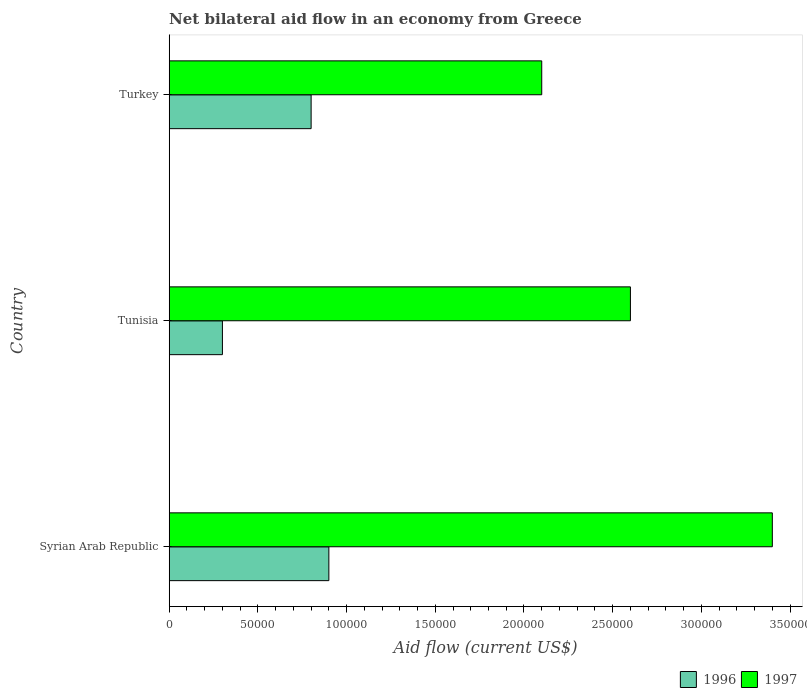How many different coloured bars are there?
Provide a short and direct response. 2. Are the number of bars per tick equal to the number of legend labels?
Your answer should be very brief. Yes. Are the number of bars on each tick of the Y-axis equal?
Your response must be concise. Yes. In how many cases, is the number of bars for a given country not equal to the number of legend labels?
Make the answer very short. 0. In which country was the net bilateral aid flow in 1996 maximum?
Provide a short and direct response. Syrian Arab Republic. In which country was the net bilateral aid flow in 1997 minimum?
Your response must be concise. Turkey. What is the total net bilateral aid flow in 1996 in the graph?
Ensure brevity in your answer.  2.00e+05. What is the difference between the net bilateral aid flow in 1997 in Syrian Arab Republic and that in Tunisia?
Ensure brevity in your answer.  8.00e+04. In how many countries, is the net bilateral aid flow in 1997 greater than 60000 US$?
Provide a succinct answer. 3. What is the ratio of the net bilateral aid flow in 1997 in Syrian Arab Republic to that in Turkey?
Give a very brief answer. 1.62. In how many countries, is the net bilateral aid flow in 1997 greater than the average net bilateral aid flow in 1997 taken over all countries?
Make the answer very short. 1. Is the sum of the net bilateral aid flow in 1996 in Tunisia and Turkey greater than the maximum net bilateral aid flow in 1997 across all countries?
Your response must be concise. No. What does the 1st bar from the top in Turkey represents?
Offer a terse response. 1997. How many countries are there in the graph?
Ensure brevity in your answer.  3. What is the difference between two consecutive major ticks on the X-axis?
Ensure brevity in your answer.  5.00e+04. Where does the legend appear in the graph?
Keep it short and to the point. Bottom right. How many legend labels are there?
Keep it short and to the point. 2. What is the title of the graph?
Provide a short and direct response. Net bilateral aid flow in an economy from Greece. What is the label or title of the X-axis?
Make the answer very short. Aid flow (current US$). What is the label or title of the Y-axis?
Keep it short and to the point. Country. What is the Aid flow (current US$) in 1996 in Tunisia?
Your answer should be compact. 3.00e+04. What is the Aid flow (current US$) in 1997 in Tunisia?
Your answer should be compact. 2.60e+05. What is the Aid flow (current US$) of 1997 in Turkey?
Your answer should be compact. 2.10e+05. Across all countries, what is the maximum Aid flow (current US$) in 1996?
Your answer should be compact. 9.00e+04. Across all countries, what is the maximum Aid flow (current US$) of 1997?
Your answer should be compact. 3.40e+05. What is the total Aid flow (current US$) of 1997 in the graph?
Provide a short and direct response. 8.10e+05. What is the difference between the Aid flow (current US$) of 1997 in Syrian Arab Republic and that in Tunisia?
Provide a succinct answer. 8.00e+04. What is the difference between the Aid flow (current US$) of 1996 in Syrian Arab Republic and that in Turkey?
Provide a short and direct response. 10000. What is the difference between the Aid flow (current US$) of 1997 in Syrian Arab Republic and that in Turkey?
Your answer should be compact. 1.30e+05. What is the difference between the Aid flow (current US$) in 1996 in Syrian Arab Republic and the Aid flow (current US$) in 1997 in Tunisia?
Keep it short and to the point. -1.70e+05. What is the difference between the Aid flow (current US$) of 1996 in Syrian Arab Republic and the Aid flow (current US$) of 1997 in Turkey?
Provide a succinct answer. -1.20e+05. What is the difference between the Aid flow (current US$) in 1996 in Tunisia and the Aid flow (current US$) in 1997 in Turkey?
Provide a succinct answer. -1.80e+05. What is the average Aid flow (current US$) of 1996 per country?
Offer a terse response. 6.67e+04. What is the ratio of the Aid flow (current US$) of 1996 in Syrian Arab Republic to that in Tunisia?
Offer a terse response. 3. What is the ratio of the Aid flow (current US$) of 1997 in Syrian Arab Republic to that in Tunisia?
Your response must be concise. 1.31. What is the ratio of the Aid flow (current US$) of 1997 in Syrian Arab Republic to that in Turkey?
Your answer should be compact. 1.62. What is the ratio of the Aid flow (current US$) in 1997 in Tunisia to that in Turkey?
Offer a very short reply. 1.24. What is the difference between the highest and the lowest Aid flow (current US$) of 1997?
Give a very brief answer. 1.30e+05. 